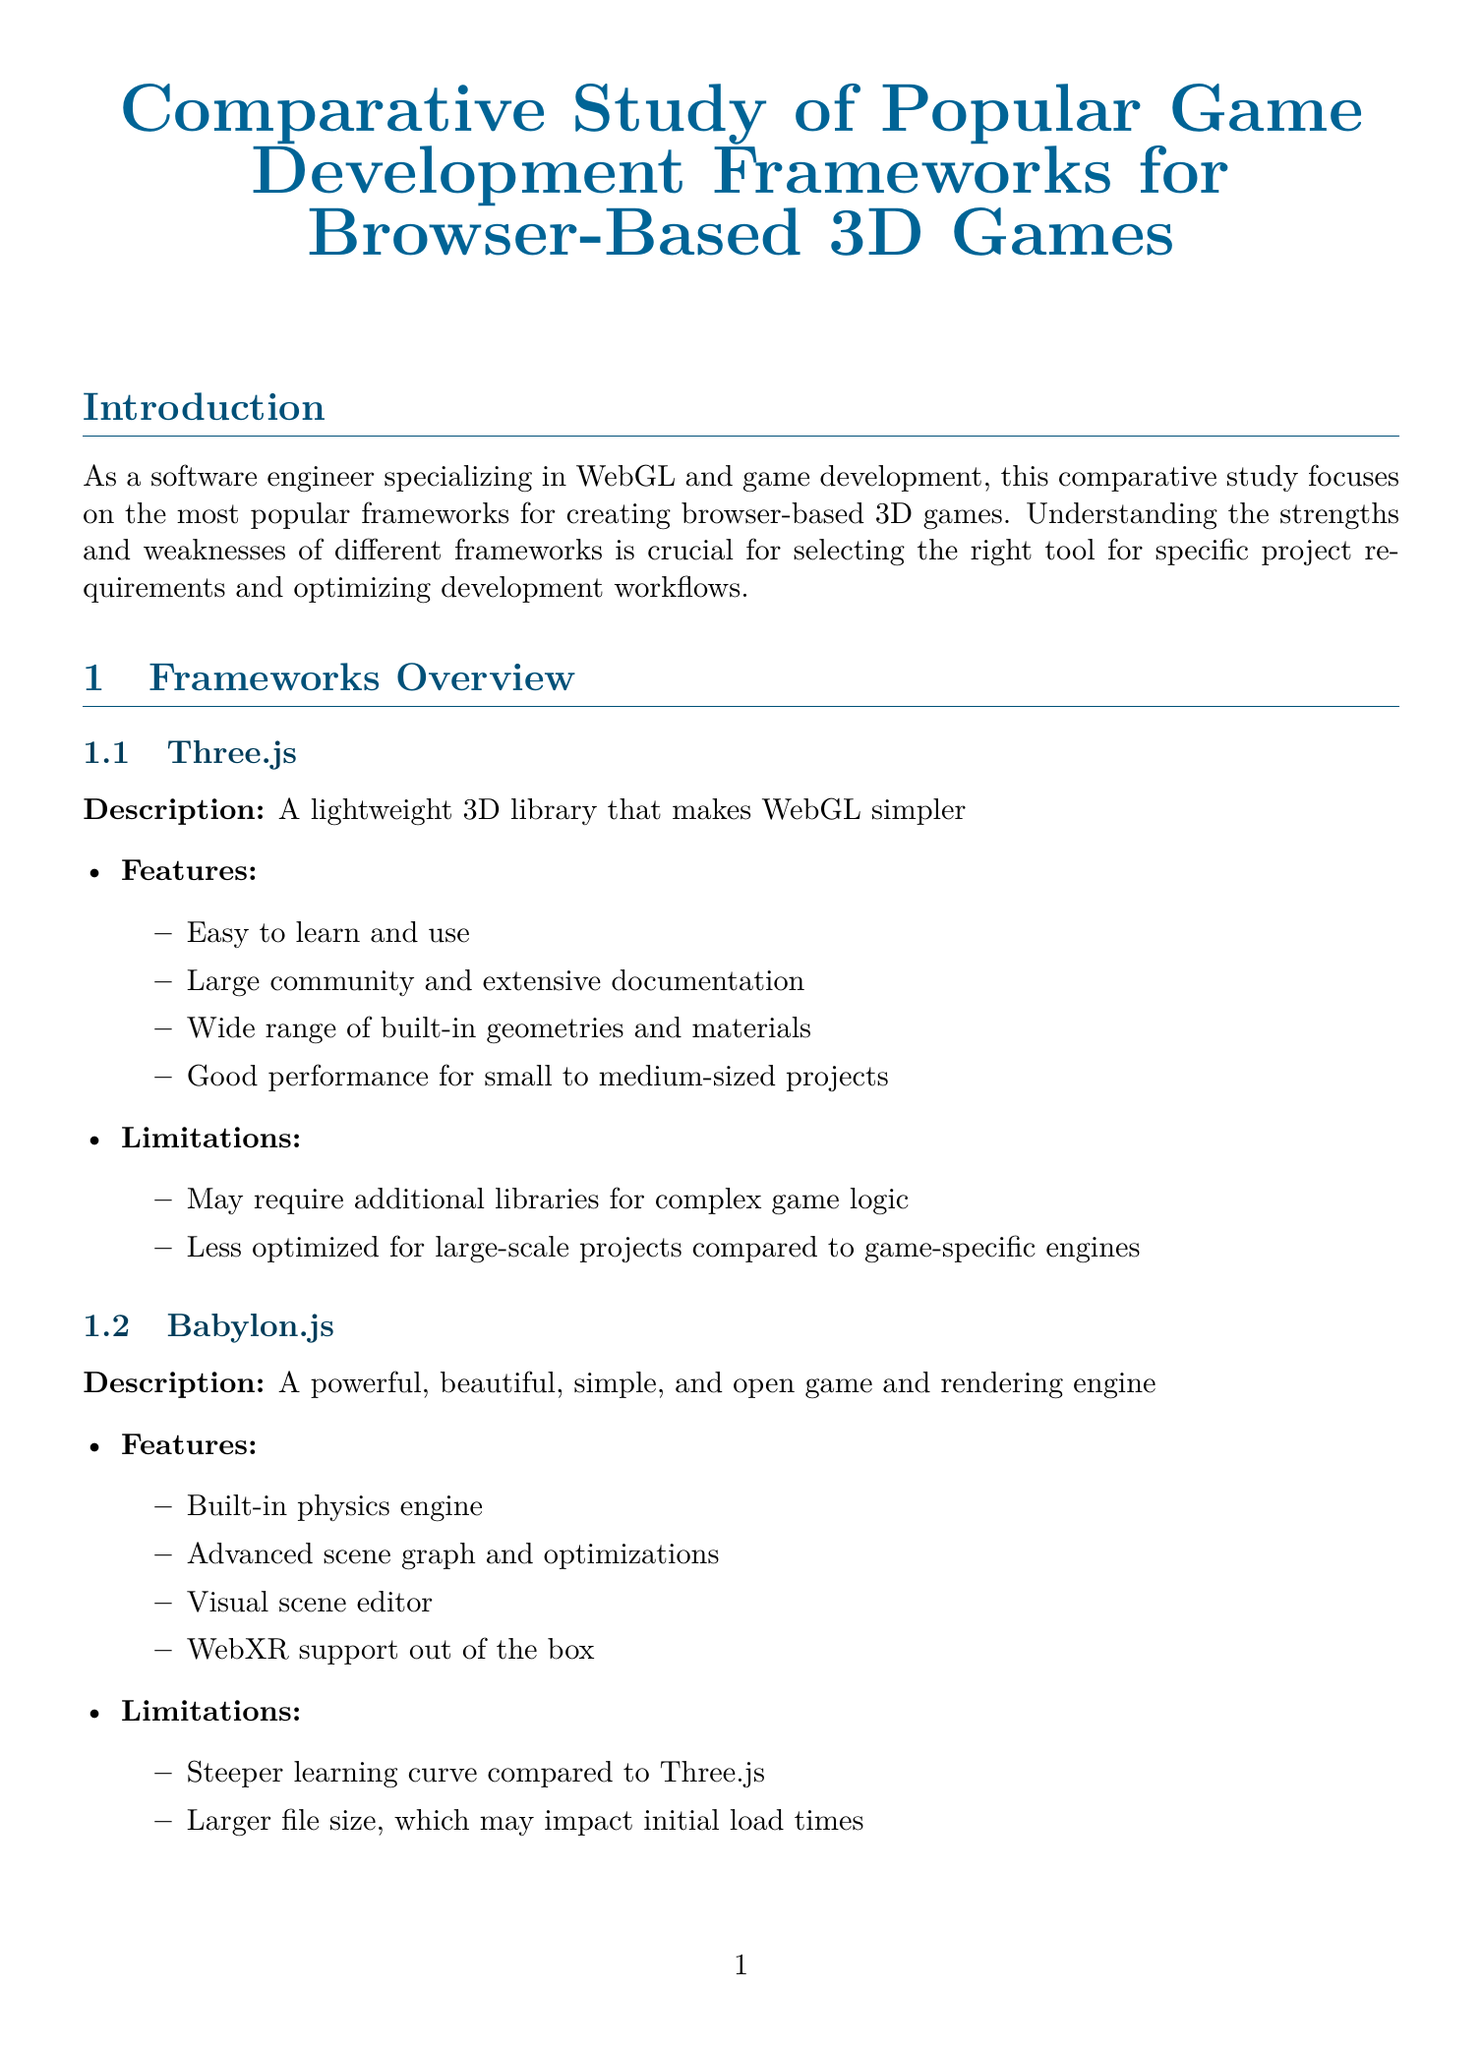What is the title of the report? The title of the report is found at the beginning of the document.
Answer: Comparative Study of Popular Game Development Frameworks for Browser-Based 3D Games What is the recommended framework for simple 3D visualization? The recommendation for simple 3D visualization is mentioned in the use cases section.
Answer: Three.js What is the load time for Babylon.js? Load time for Babylon.js can be found in the performance comparison table.
Answer: 1.5 seconds Which framework has the highest memory usage? The framework with the highest memory usage is derived from the performance comparison section.
Answer: Babylon.js What is the learning curve for PlayCanvas? The learning curve information is provided in the development experience section.
Answer: Medium What are the future trends mentioned in the report? The future trends are listed and can be referenced in the corresponding section.
Answer: Increased focus on WebGPU support for improved performance What is the limitation of PlayCanvas? Limitations for PlayCanvas are detailed in the frameworks overview section.
Answer: Requires internet connection for development in the web-based editor What is the FPS for Three.js in the performance comparison? FPS for Three.js is indicated in the performance comparison results table.
Answer: 58 